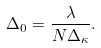Convert formula to latex. <formula><loc_0><loc_0><loc_500><loc_500>\Delta _ { 0 } = \frac { \lambda } { N \Delta _ { \kappa } } .</formula> 